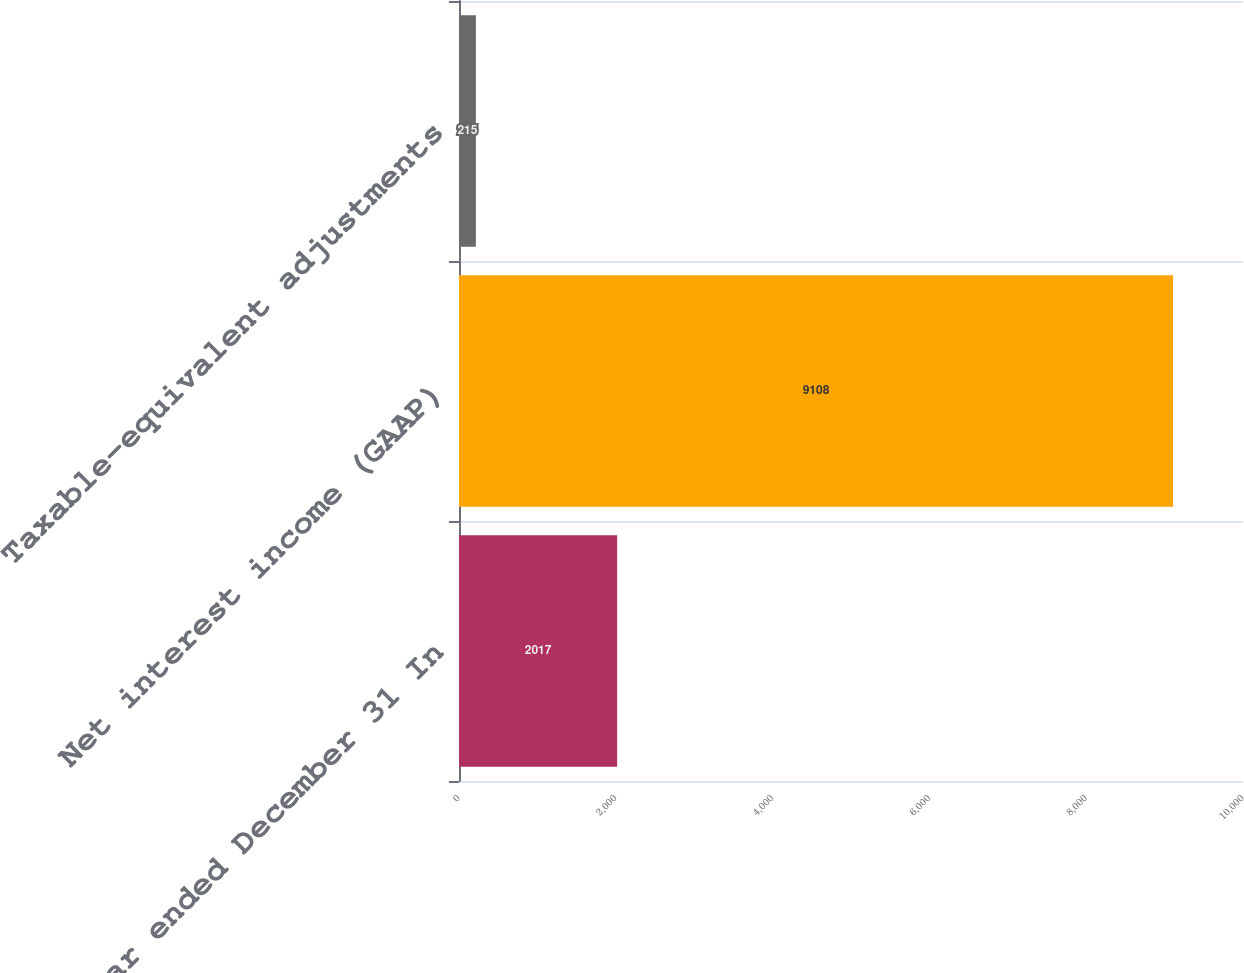Convert chart. <chart><loc_0><loc_0><loc_500><loc_500><bar_chart><fcel>Year ended December 31 In<fcel>Net interest income (GAAP)<fcel>Taxable-equivalent adjustments<nl><fcel>2017<fcel>9108<fcel>215<nl></chart> 